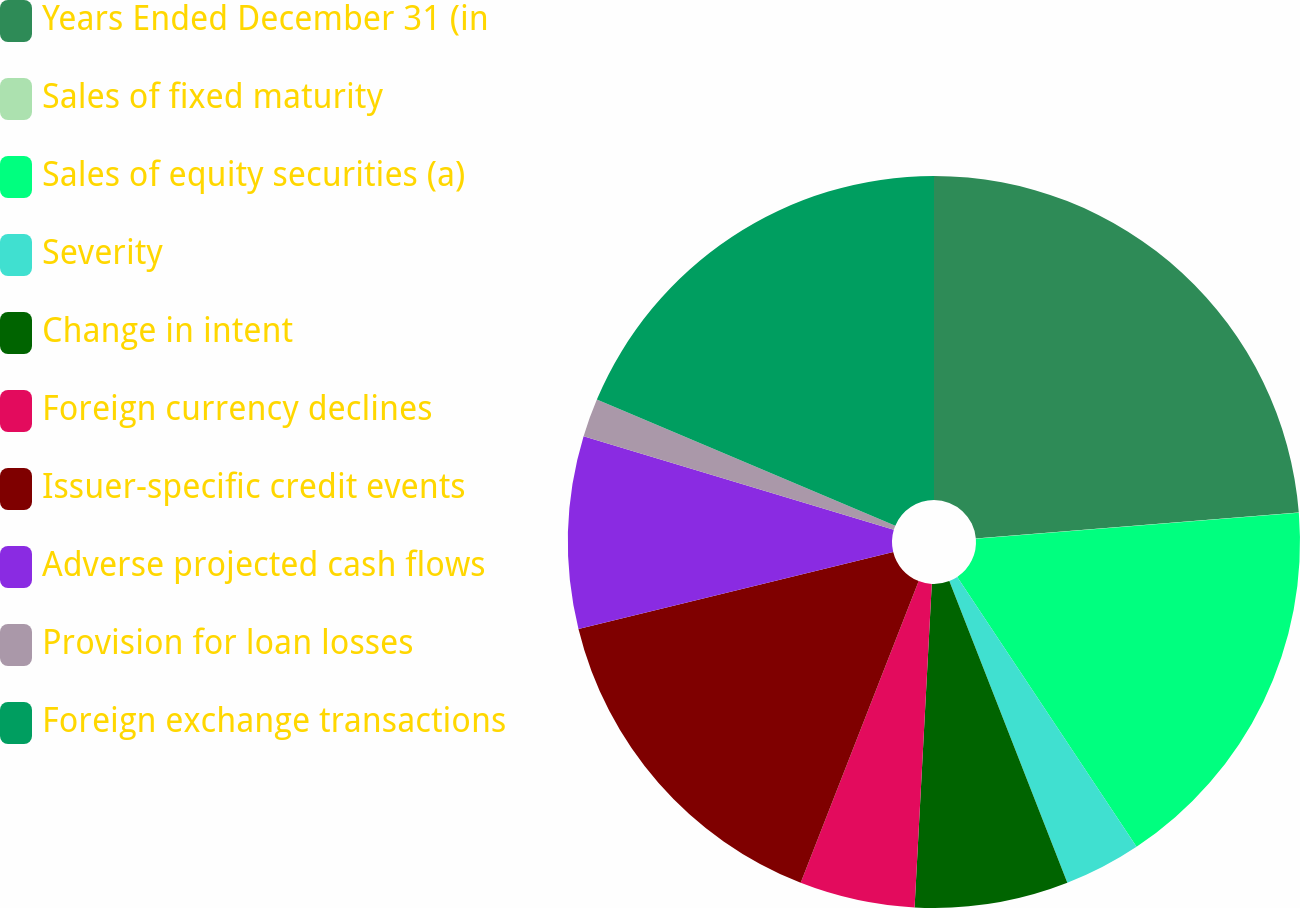Convert chart to OTSL. <chart><loc_0><loc_0><loc_500><loc_500><pie_chart><fcel>Years Ended December 31 (in<fcel>Sales of fixed maturity<fcel>Sales of equity securities (a)<fcel>Severity<fcel>Change in intent<fcel>Foreign currency declines<fcel>Issuer-specific credit events<fcel>Adverse projected cash flows<fcel>Provision for loan losses<fcel>Foreign exchange transactions<nl><fcel>23.72%<fcel>0.01%<fcel>16.94%<fcel>3.4%<fcel>6.78%<fcel>5.09%<fcel>15.25%<fcel>8.48%<fcel>1.7%<fcel>18.64%<nl></chart> 